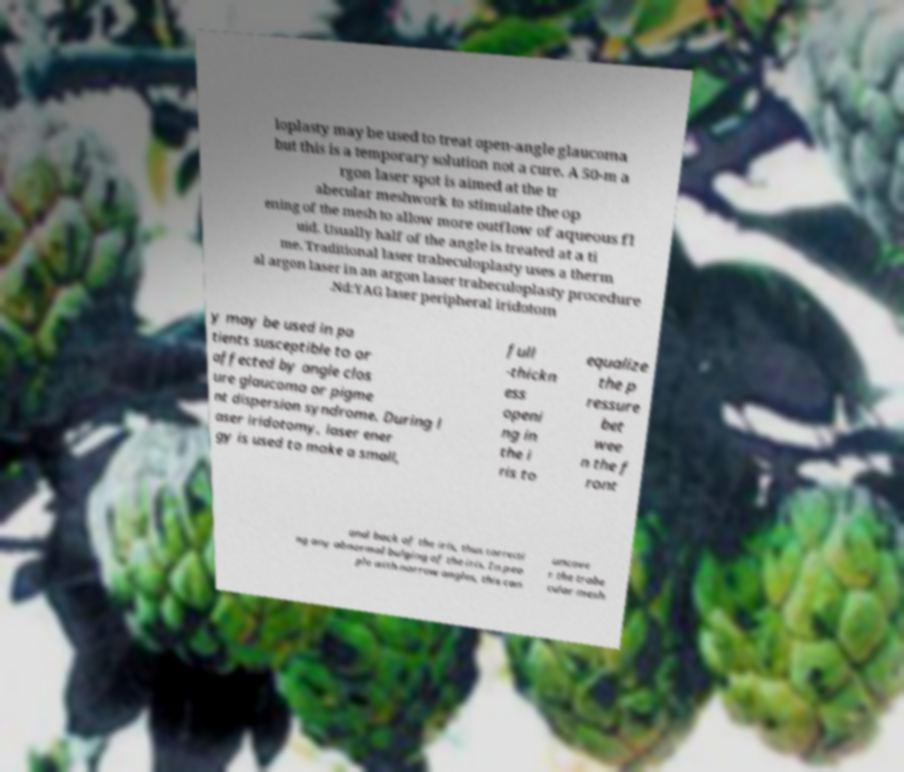Can you read and provide the text displayed in the image?This photo seems to have some interesting text. Can you extract and type it out for me? loplasty may be used to treat open-angle glaucoma but this is a temporary solution not a cure. A 50-m a rgon laser spot is aimed at the tr abecular meshwork to stimulate the op ening of the mesh to allow more outflow of aqueous fl uid. Usually half of the angle is treated at a ti me. Traditional laser trabeculoplasty uses a therm al argon laser in an argon laser trabeculoplasty procedure .Nd:YAG laser peripheral iridotom y may be used in pa tients susceptible to or affected by angle clos ure glaucoma or pigme nt dispersion syndrome. During l aser iridotomy, laser ener gy is used to make a small, full -thickn ess openi ng in the i ris to equalize the p ressure bet wee n the f ront and back of the iris, thus correcti ng any abnormal bulging of the iris. In peo ple with narrow angles, this can uncove r the trabe cular mesh 